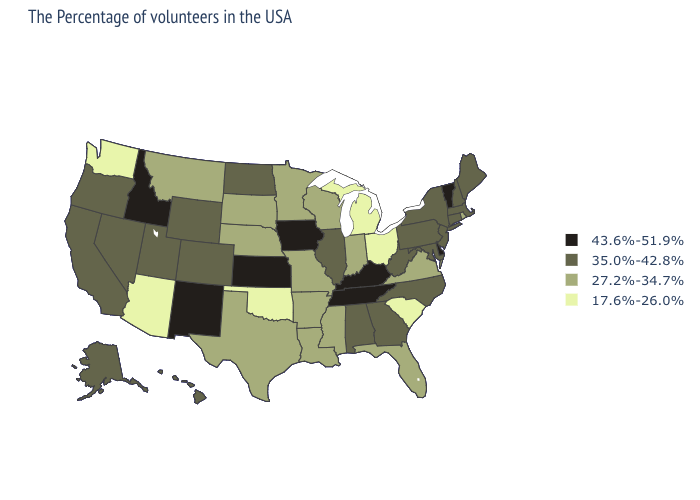Does Minnesota have a higher value than Kansas?
Answer briefly. No. Name the states that have a value in the range 17.6%-26.0%?
Give a very brief answer. South Carolina, Ohio, Michigan, Oklahoma, Arizona, Washington. Name the states that have a value in the range 43.6%-51.9%?
Answer briefly. Vermont, Delaware, Kentucky, Tennessee, Iowa, Kansas, New Mexico, Idaho. What is the value of Michigan?
Write a very short answer. 17.6%-26.0%. What is the lowest value in the USA?
Short answer required. 17.6%-26.0%. Does Kentucky have the highest value in the USA?
Concise answer only. Yes. Among the states that border New Hampshire , does Massachusetts have the highest value?
Concise answer only. No. What is the value of Rhode Island?
Give a very brief answer. 27.2%-34.7%. What is the value of Georgia?
Write a very short answer. 35.0%-42.8%. Is the legend a continuous bar?
Write a very short answer. No. What is the value of Hawaii?
Keep it brief. 35.0%-42.8%. What is the value of Connecticut?
Quick response, please. 35.0%-42.8%. Does New York have a higher value than Arkansas?
Be succinct. Yes. Which states hav the highest value in the South?
Be succinct. Delaware, Kentucky, Tennessee. How many symbols are there in the legend?
Concise answer only. 4. 